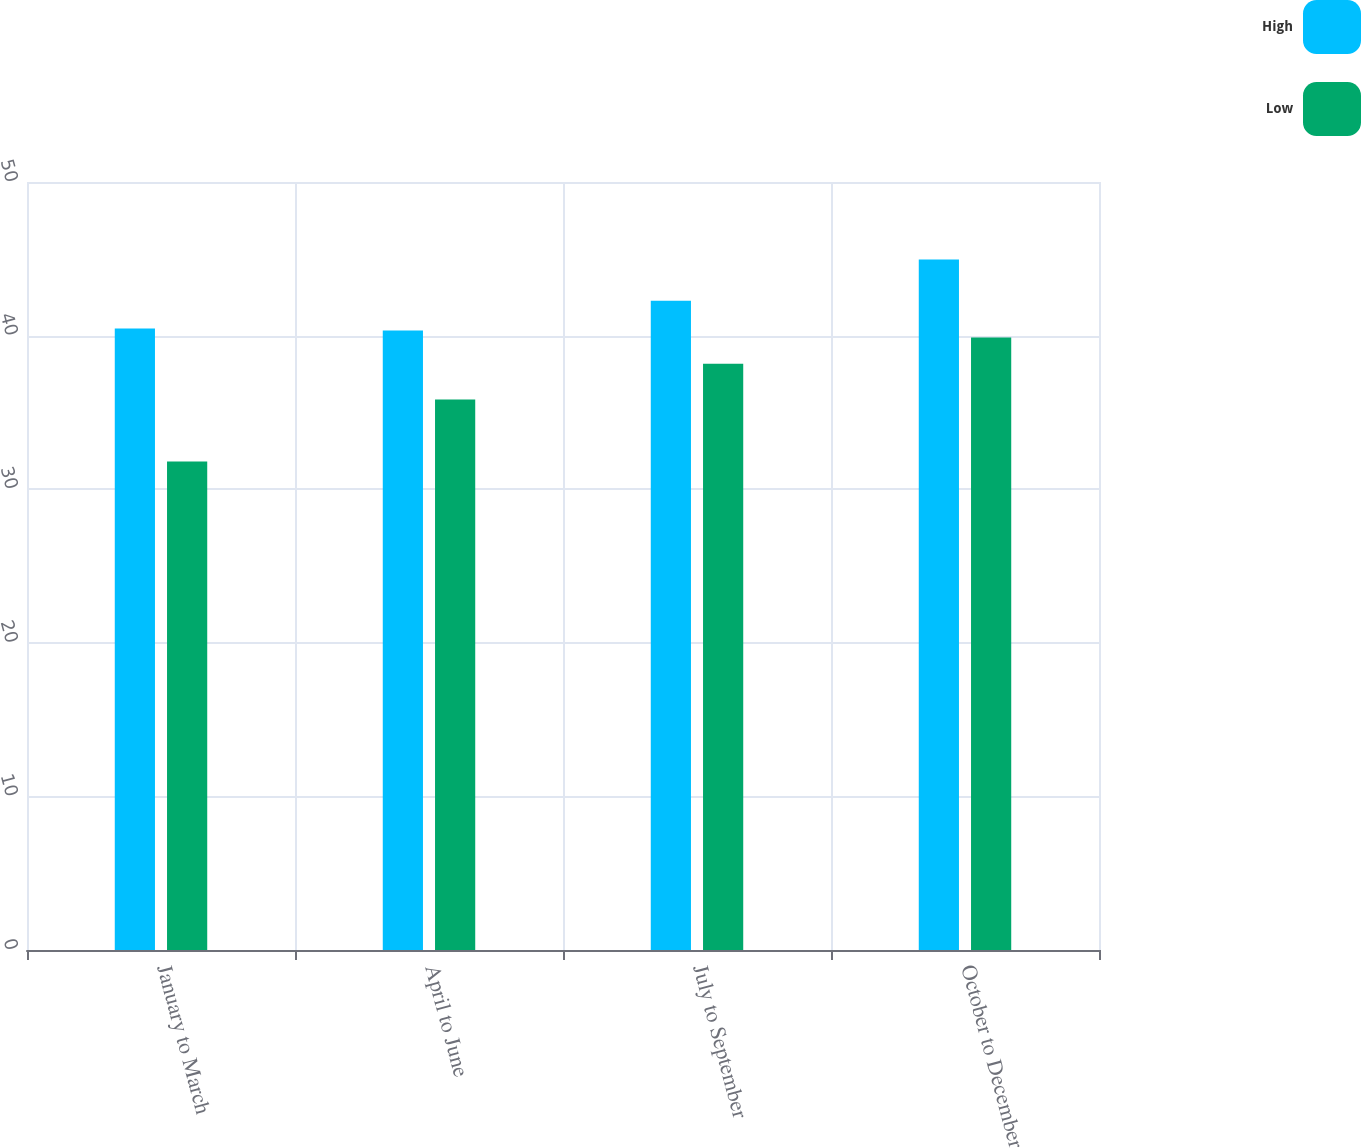Convert chart to OTSL. <chart><loc_0><loc_0><loc_500><loc_500><stacked_bar_chart><ecel><fcel>January to March<fcel>April to June<fcel>July to September<fcel>October to December<nl><fcel>High<fcel>40.46<fcel>40.33<fcel>42.27<fcel>44.96<nl><fcel>Low<fcel>31.8<fcel>35.84<fcel>38.17<fcel>39.87<nl></chart> 